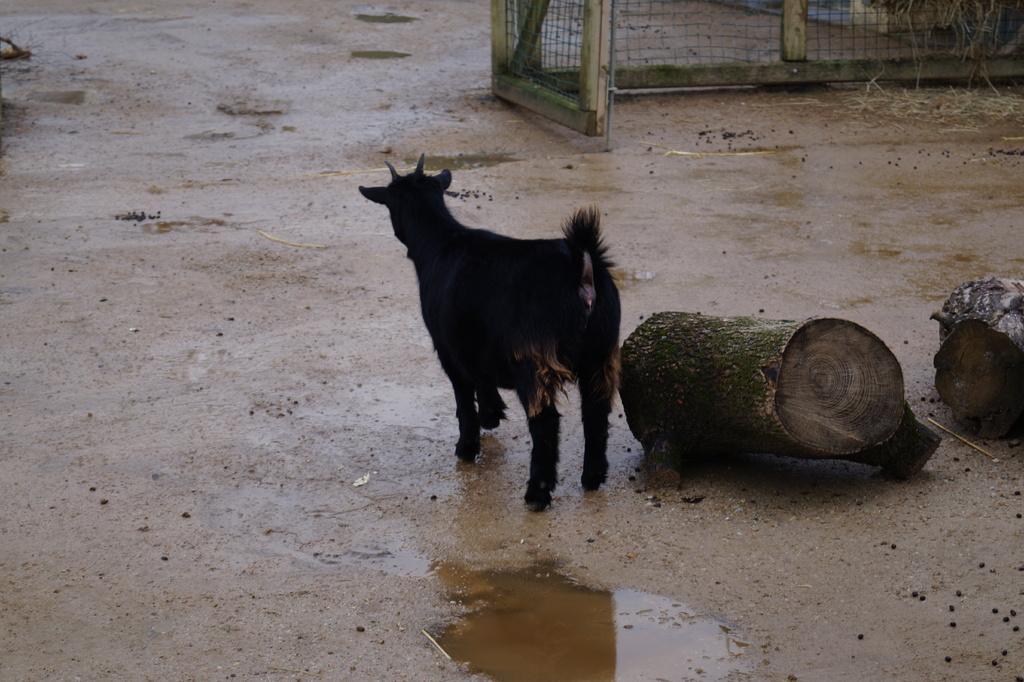Can you describe this image briefly? This picture is clicked outside. On the right we can see the wooden objects lying on the ground. In the center we can see a black color animal seems to be standing on the ground. In the foreground we can see the water on the ground. In the background we can see the mesh and some other objects. 